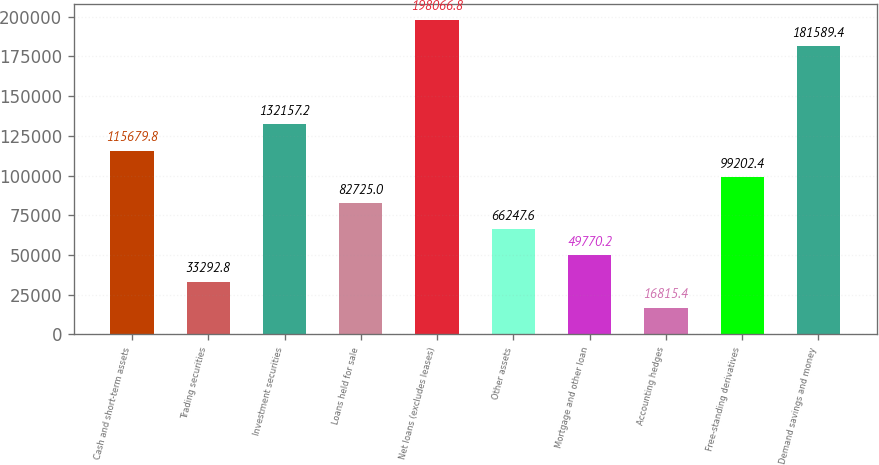Convert chart to OTSL. <chart><loc_0><loc_0><loc_500><loc_500><bar_chart><fcel>Cash and short-term assets<fcel>Trading securities<fcel>Investment securities<fcel>Loans held for sale<fcel>Net loans (excludes leases)<fcel>Other assets<fcel>Mortgage and other loan<fcel>Accounting hedges<fcel>Free-standing derivatives<fcel>Demand savings and money<nl><fcel>115680<fcel>33292.8<fcel>132157<fcel>82725<fcel>198067<fcel>66247.6<fcel>49770.2<fcel>16815.4<fcel>99202.4<fcel>181589<nl></chart> 